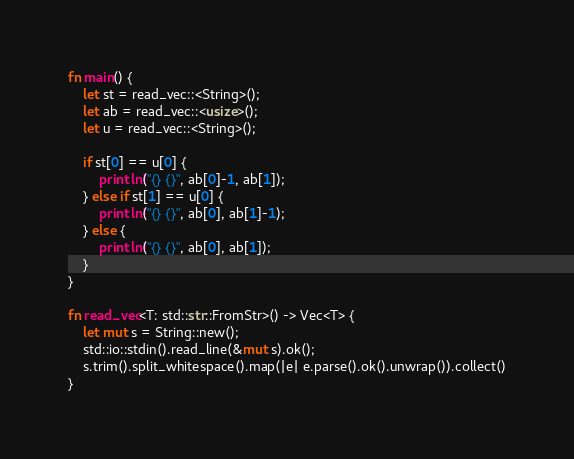Convert code to text. <code><loc_0><loc_0><loc_500><loc_500><_Rust_>fn main() {
    let st = read_vec::<String>();
    let ab = read_vec::<usize>();
    let u = read_vec::<String>();

    if st[0] == u[0] {
        println!("{} {}", ab[0]-1, ab[1]);
    } else if st[1] == u[0] {
        println!("{} {}", ab[0], ab[1]-1);
    } else {
        println!("{} {}", ab[0], ab[1]);
    }
}

fn read_vec<T: std::str::FromStr>() -> Vec<T> {
    let mut s = String::new();
    std::io::stdin().read_line(&mut s).ok();
    s.trim().split_whitespace().map(|e| e.parse().ok().unwrap()).collect()
}</code> 